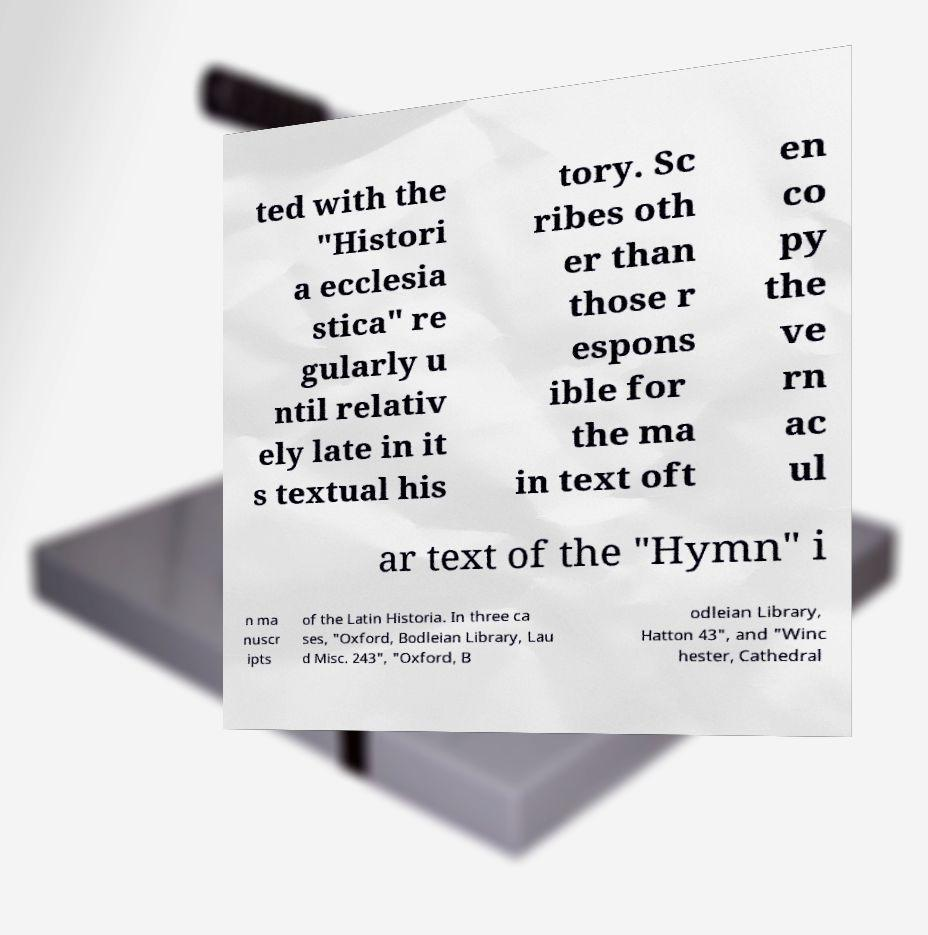Can you read and provide the text displayed in the image?This photo seems to have some interesting text. Can you extract and type it out for me? ted with the "Histori a ecclesia stica" re gularly u ntil relativ ely late in it s textual his tory. Sc ribes oth er than those r espons ible for the ma in text oft en co py the ve rn ac ul ar text of the "Hymn" i n ma nuscr ipts of the Latin Historia. In three ca ses, "Oxford, Bodleian Library, Lau d Misc. 243", "Oxford, B odleian Library, Hatton 43", and "Winc hester, Cathedral 